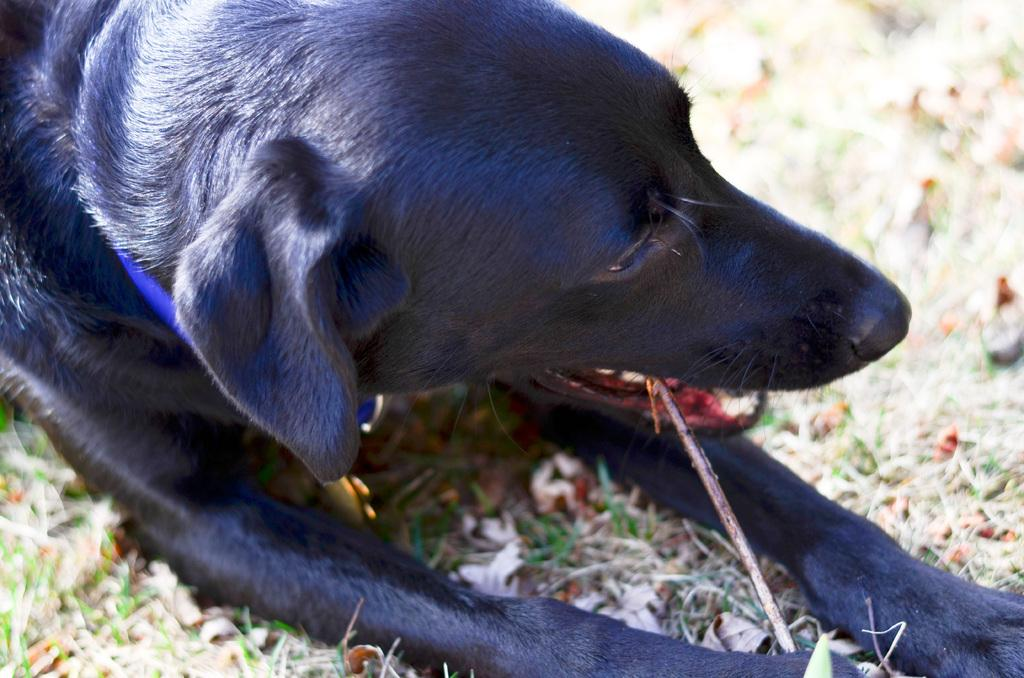What type of animal is in the image? There is a black dog in the image. Where is the dog located? The dog is on the grass. What type of bloodstain can be seen on the canvas in the image? There is no canvas or bloodstain present in the image; it features a black dog on the grass. 